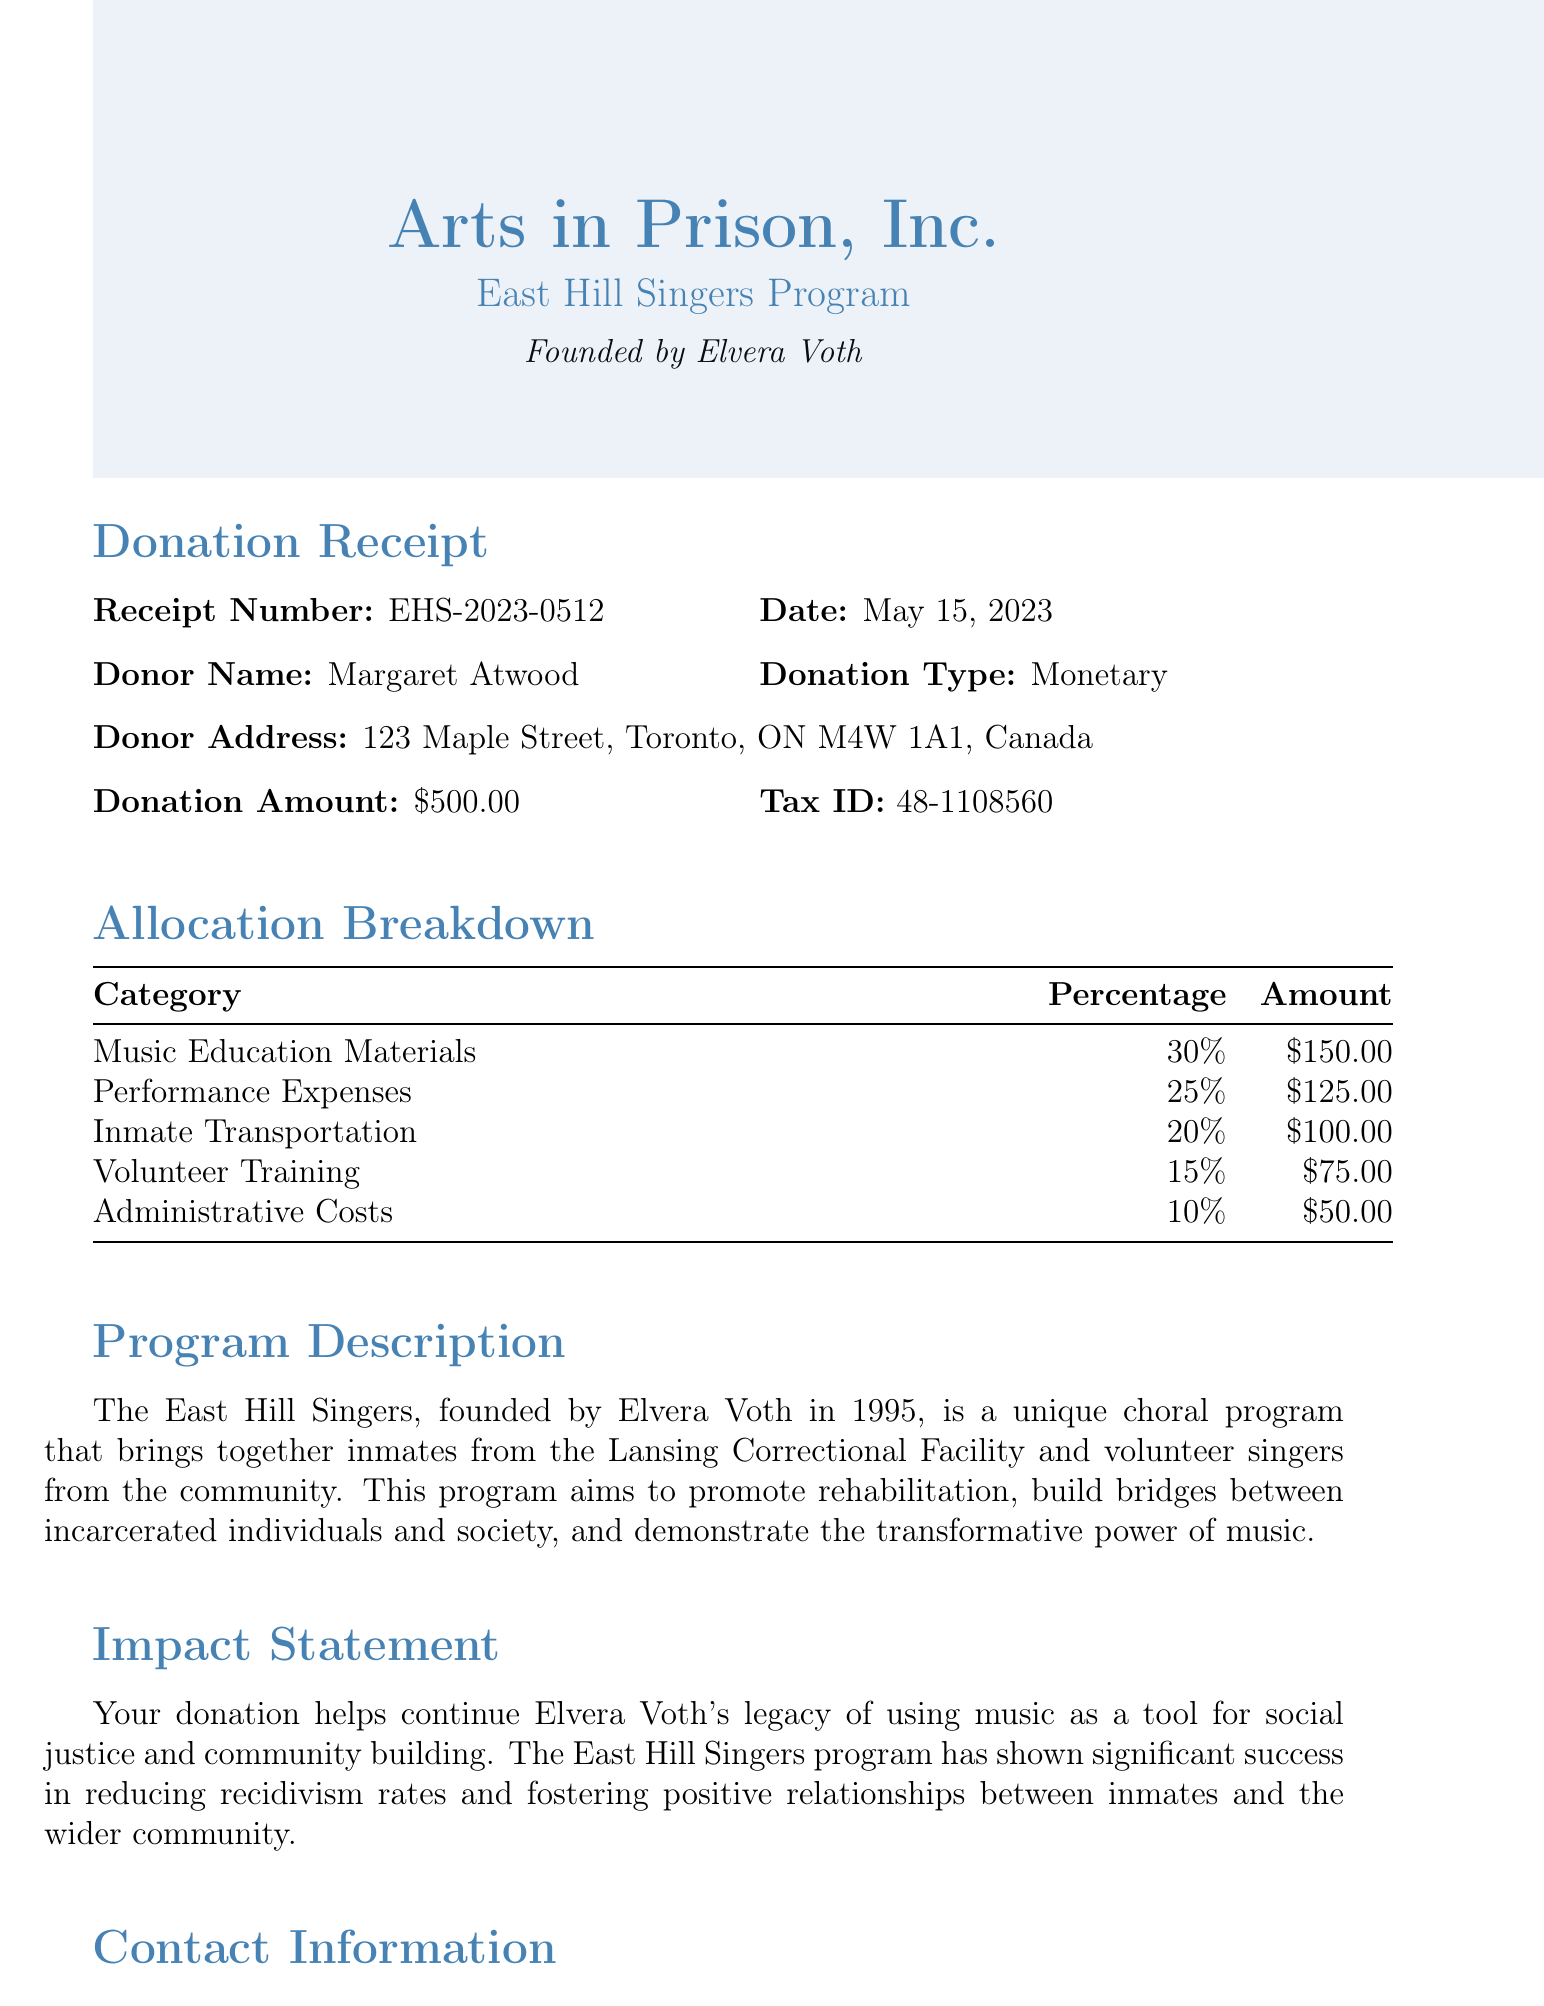What is the donor's name? The donor's name is listed under the donor information section of the receipt.
Answer: Margaret Atwood What is the donation amount? The donation amount is stated clearly in the receipt details.
Answer: $500.00 What is the donation date? The donation date can be found next to the receipt number on the document.
Answer: May 15, 2023 How much of the donation is allocated to Music Education Materials? The allocation breakdown specifies the amount designated for Music Education Materials.
Answer: $150.00 Who founded the East Hill Singers program? The founder's name is mentioned prominently in the program header.
Answer: Elvera Voth What percentage of the donation goes to Administrative Costs? The allocation breakdown outlines the percentage for Administrative Costs.
Answer: 10% What is the program description focused on? The program description provides insights into the aims and values of the East Hill Singers.
Answer: Rehabilitation and community building What is the telephone contact number? The contact information includes a dedicated telephone number.
Answer: (913) 403-0317 